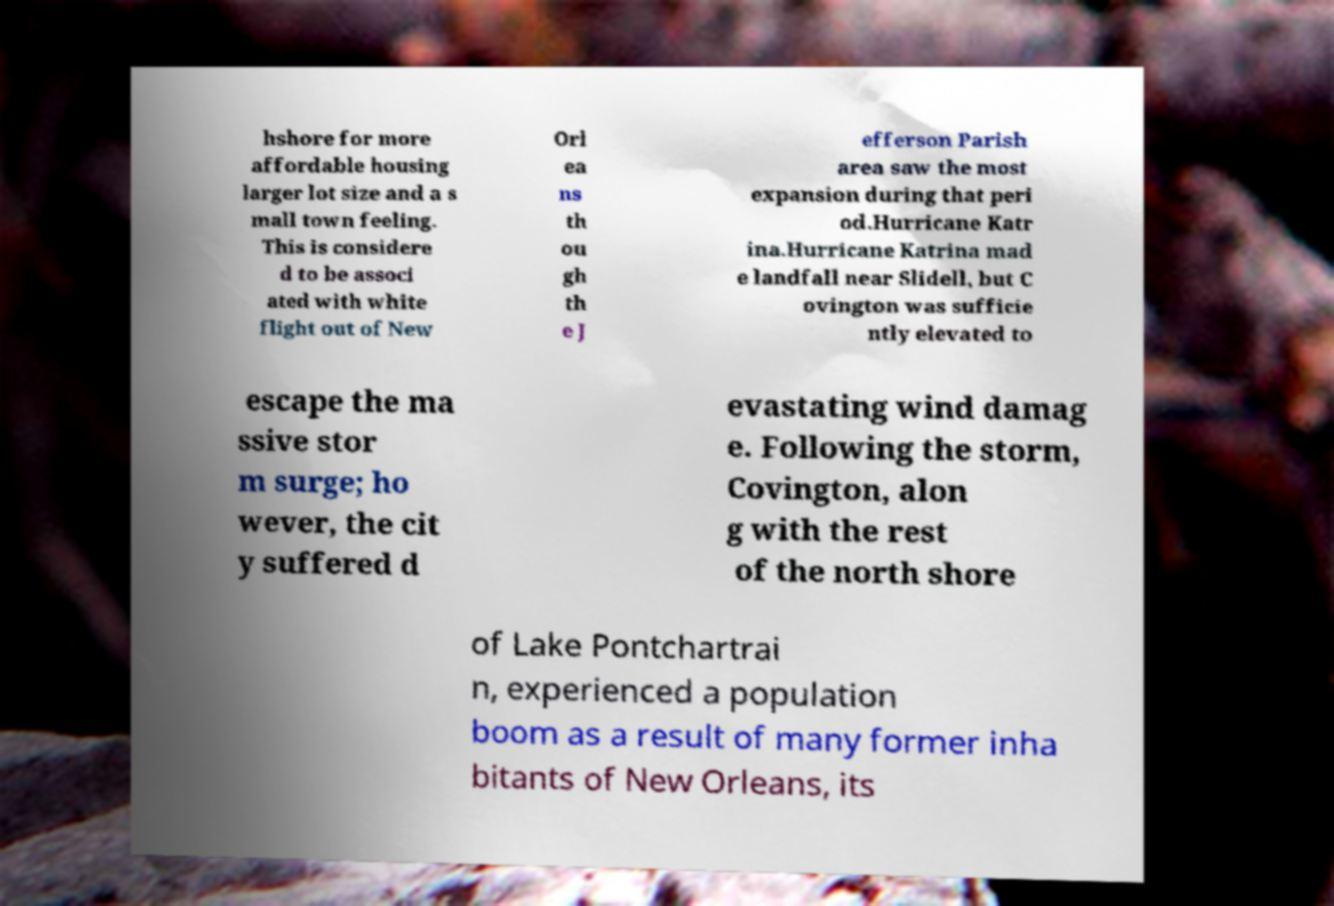There's text embedded in this image that I need extracted. Can you transcribe it verbatim? hshore for more affordable housing larger lot size and a s mall town feeling. This is considere d to be associ ated with white flight out of New Orl ea ns th ou gh th e J efferson Parish area saw the most expansion during that peri od.Hurricane Katr ina.Hurricane Katrina mad e landfall near Slidell, but C ovington was sufficie ntly elevated to escape the ma ssive stor m surge; ho wever, the cit y suffered d evastating wind damag e. Following the storm, Covington, alon g with the rest of the north shore of Lake Pontchartrai n, experienced a population boom as a result of many former inha bitants of New Orleans, its 